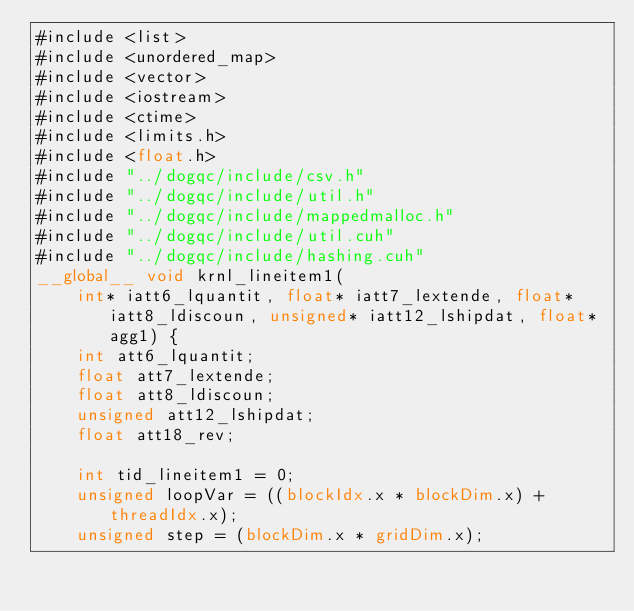<code> <loc_0><loc_0><loc_500><loc_500><_Cuda_>#include <list>
#include <unordered_map>
#include <vector>
#include <iostream>
#include <ctime>
#include <limits.h>
#include <float.h>
#include "../dogqc/include/csv.h"
#include "../dogqc/include/util.h"
#include "../dogqc/include/mappedmalloc.h"
#include "../dogqc/include/util.cuh"
#include "../dogqc/include/hashing.cuh"
__global__ void krnl_lineitem1(
    int* iatt6_lquantit, float* iatt7_lextende, float* iatt8_ldiscoun, unsigned* iatt12_lshipdat, float* agg1) {
    int att6_lquantit;
    float att7_lextende;
    float att8_ldiscoun;
    unsigned att12_lshipdat;
    float att18_rev;

    int tid_lineitem1 = 0;
    unsigned loopVar = ((blockIdx.x * blockDim.x) + threadIdx.x);
    unsigned step = (blockDim.x * gridDim.x);</code> 